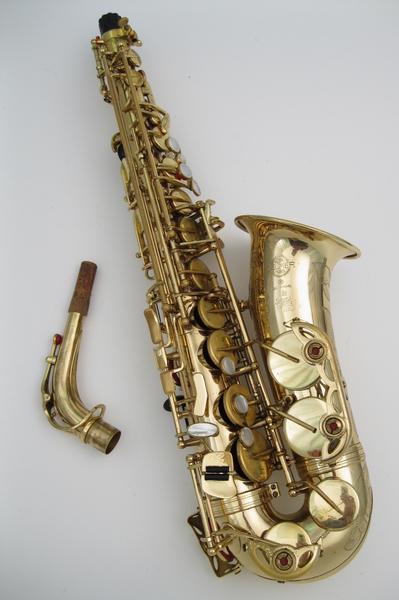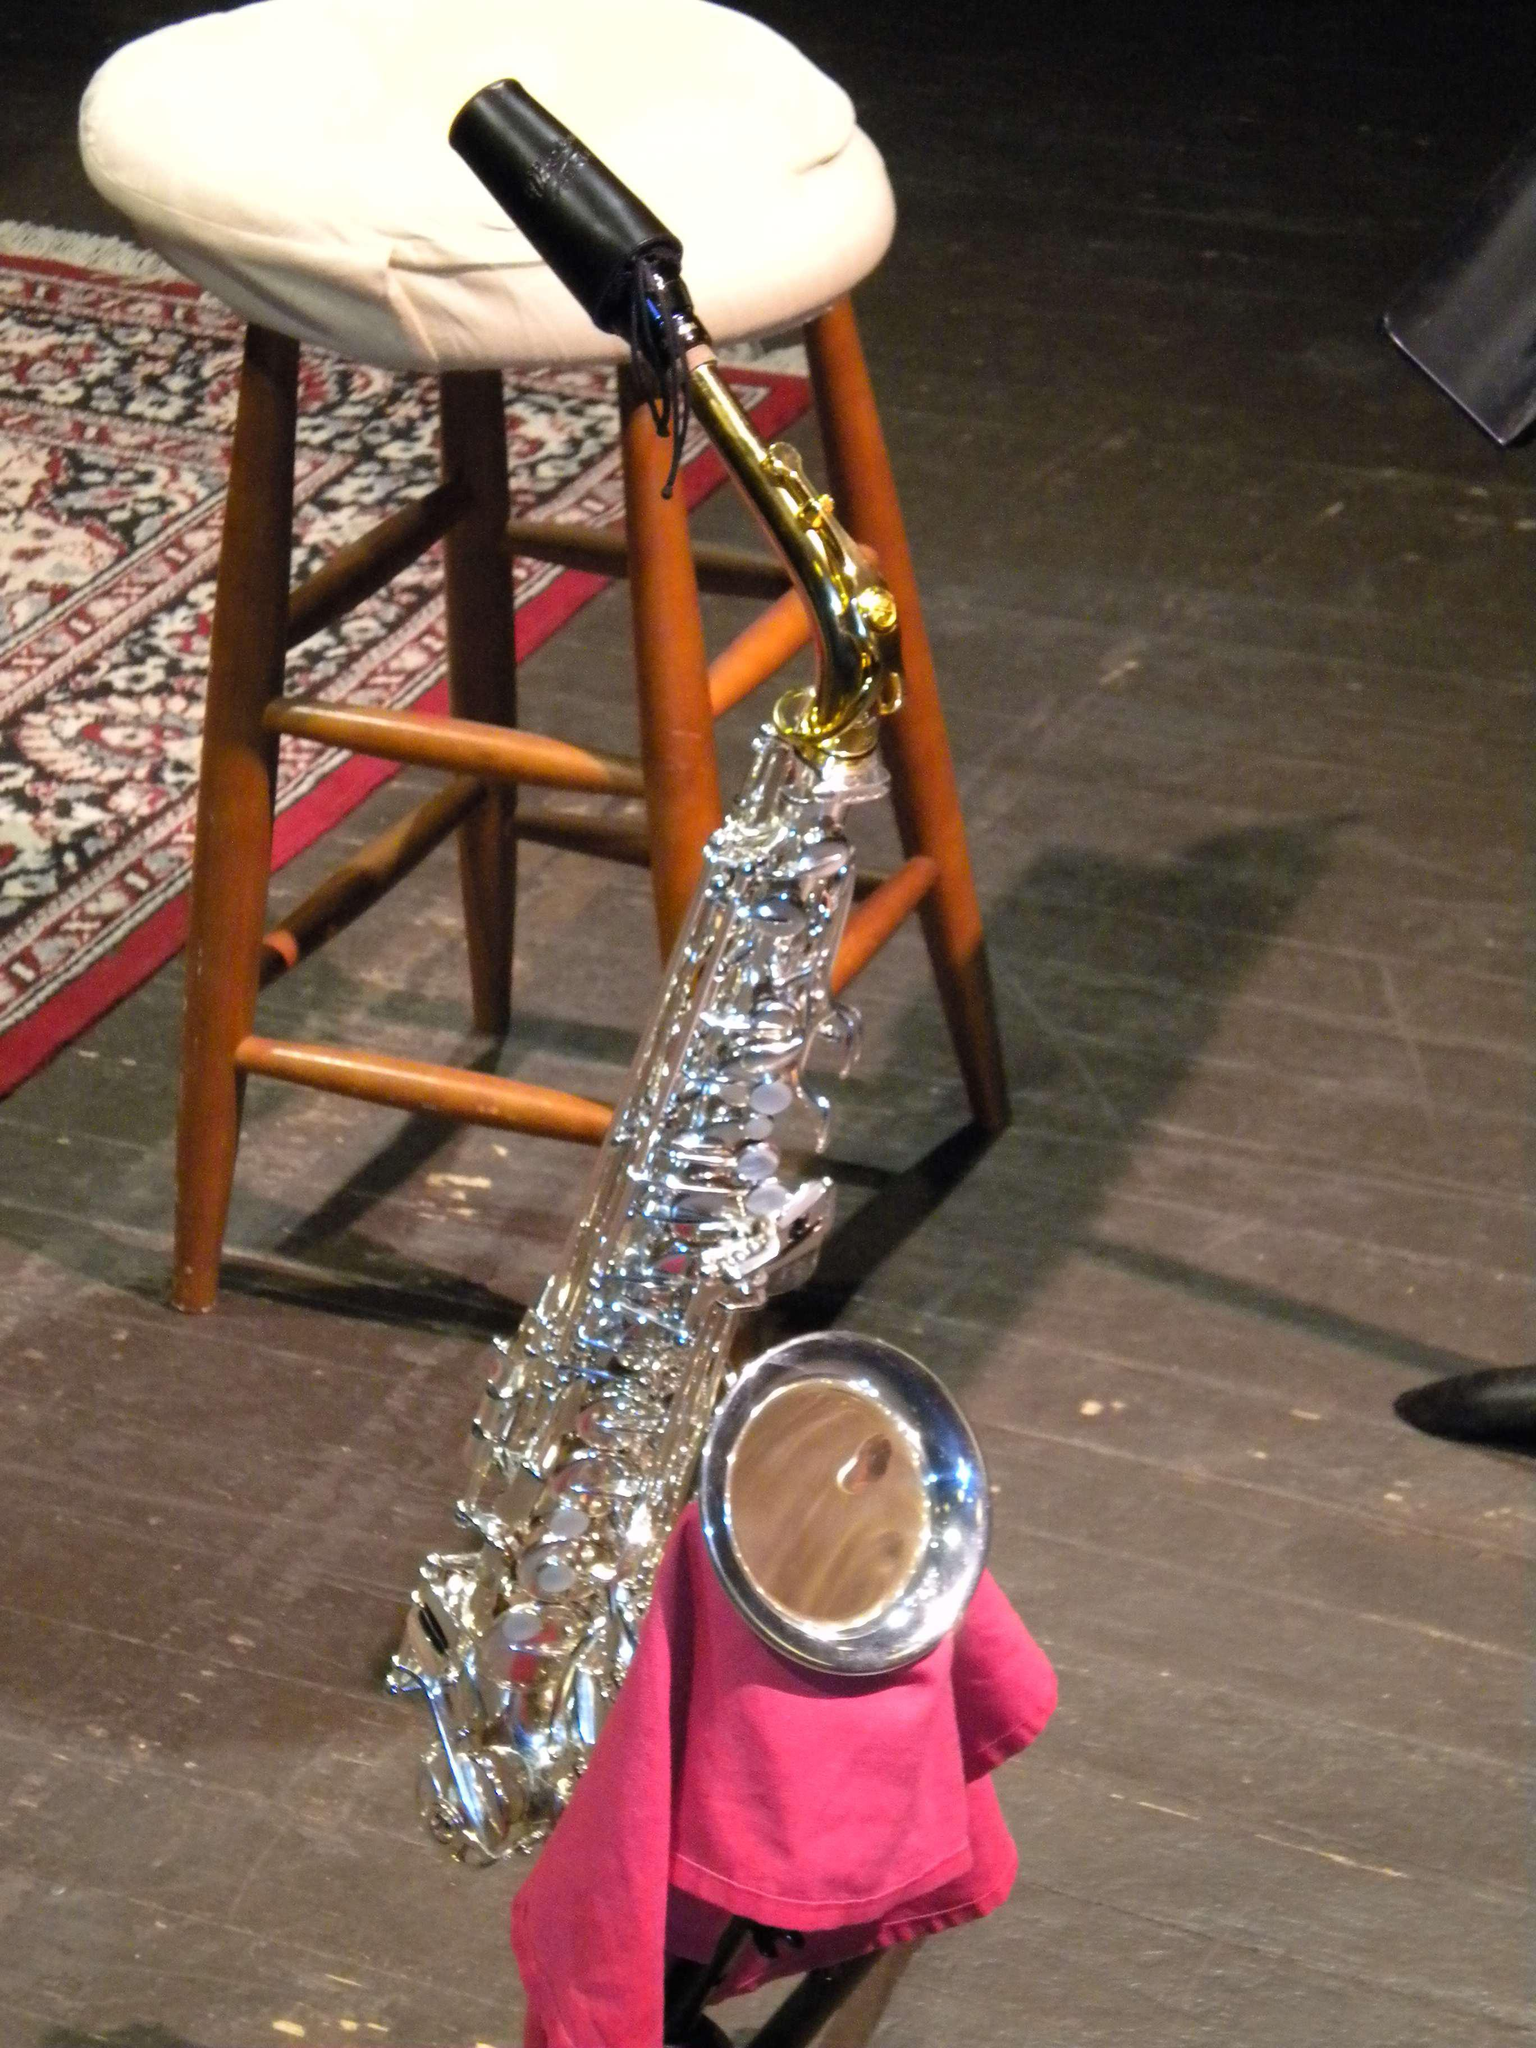The first image is the image on the left, the second image is the image on the right. Assess this claim about the two images: "An image shows a brass-colored saxophone held upright on a blacks stand.". Correct or not? Answer yes or no. No. 